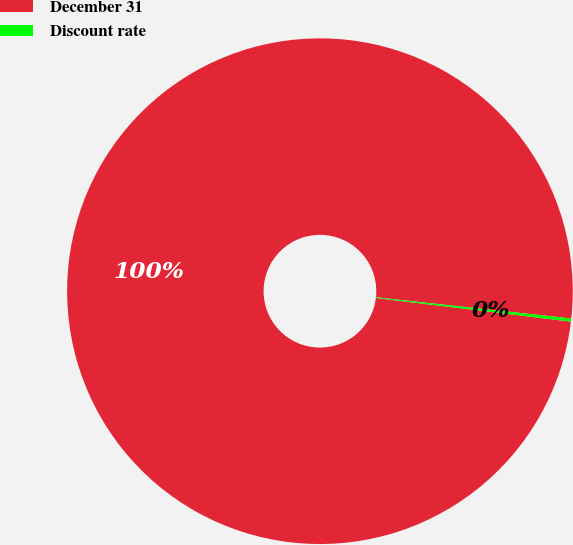Convert chart. <chart><loc_0><loc_0><loc_500><loc_500><pie_chart><fcel>December 31<fcel>Discount rate<nl><fcel>99.8%<fcel>0.2%<nl></chart> 